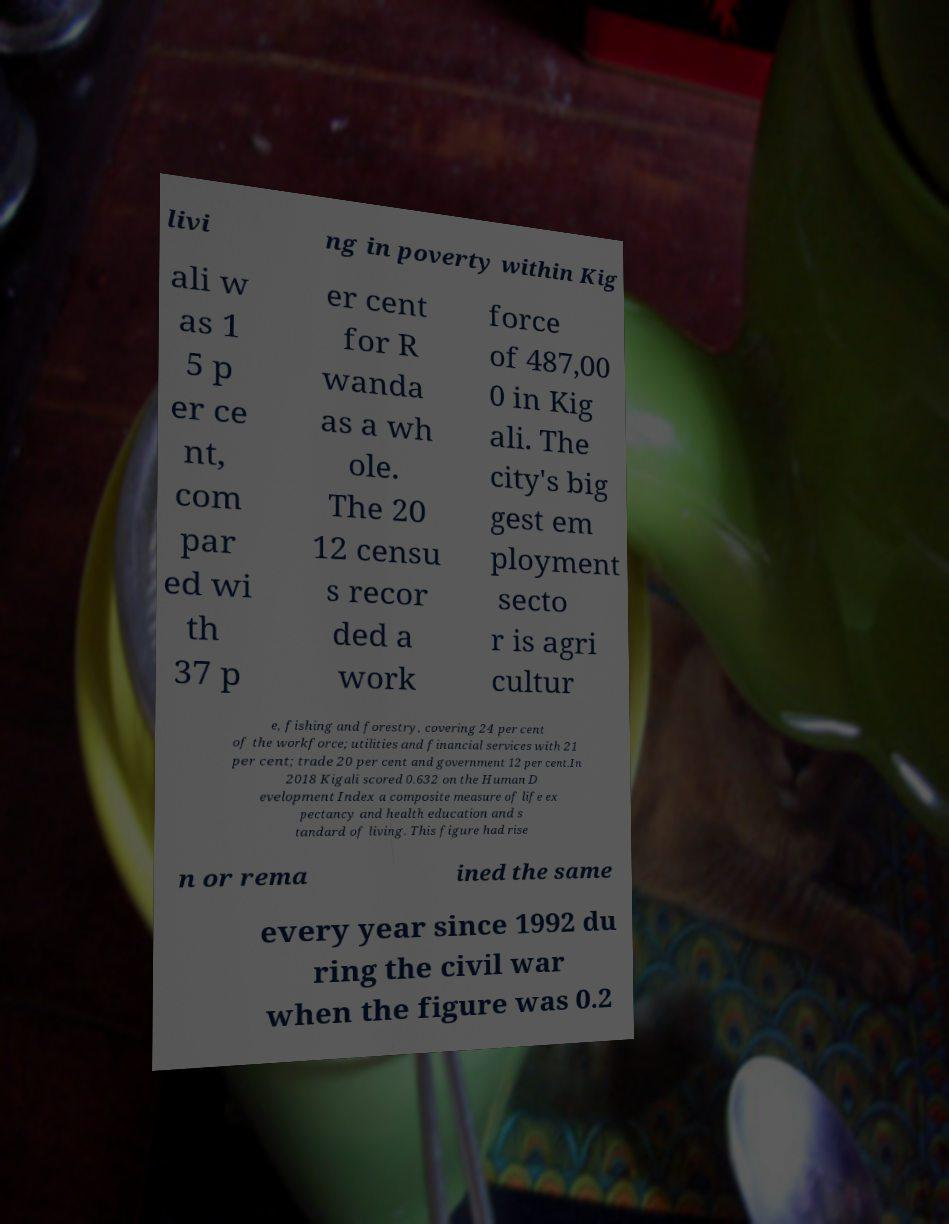Could you assist in decoding the text presented in this image and type it out clearly? livi ng in poverty within Kig ali w as 1 5 p er ce nt, com par ed wi th 37 p er cent for R wanda as a wh ole. The 20 12 censu s recor ded a work force of 487,00 0 in Kig ali. The city's big gest em ployment secto r is agri cultur e, fishing and forestry, covering 24 per cent of the workforce; utilities and financial services with 21 per cent; trade 20 per cent and government 12 per cent.In 2018 Kigali scored 0.632 on the Human D evelopment Index a composite measure of life ex pectancy and health education and s tandard of living. This figure had rise n or rema ined the same every year since 1992 du ring the civil war when the figure was 0.2 